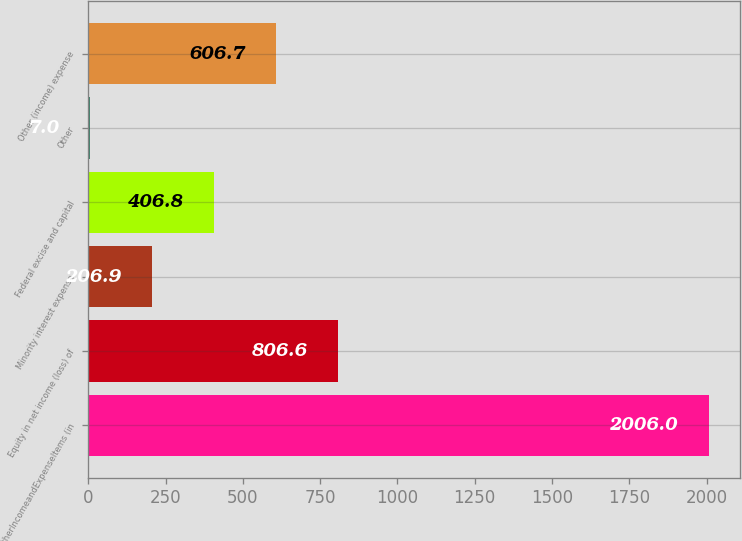Convert chart to OTSL. <chart><loc_0><loc_0><loc_500><loc_500><bar_chart><fcel>OtherIncomeandExpenseItems (in<fcel>Equity in net income (loss) of<fcel>Minority interest expense<fcel>Federal excise and capital<fcel>Other<fcel>Other (income) expense<nl><fcel>2006<fcel>806.6<fcel>206.9<fcel>406.8<fcel>7<fcel>606.7<nl></chart> 